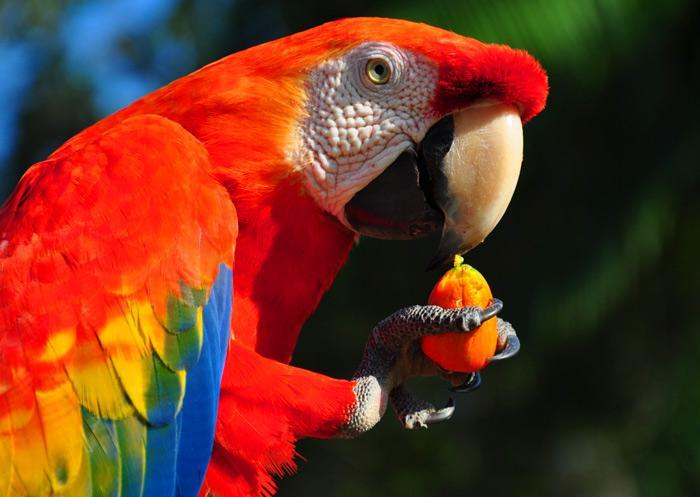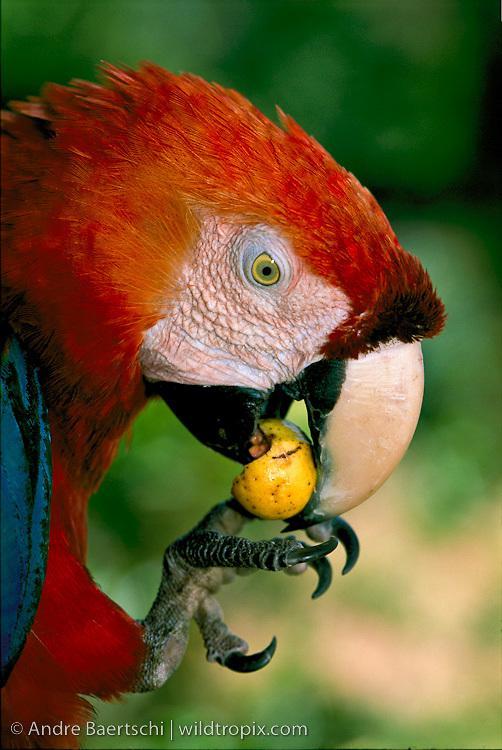The first image is the image on the left, the second image is the image on the right. Analyze the images presented: Is the assertion "A bird looking to the left has something green in its mouth." valid? Answer yes or no. No. The first image is the image on the left, the second image is the image on the right. Considering the images on both sides, is "Each image shows a red-headed bird surrounded by foliage, and in one image, the bird holds a green nut in its beak without using its claw." valid? Answer yes or no. No. 